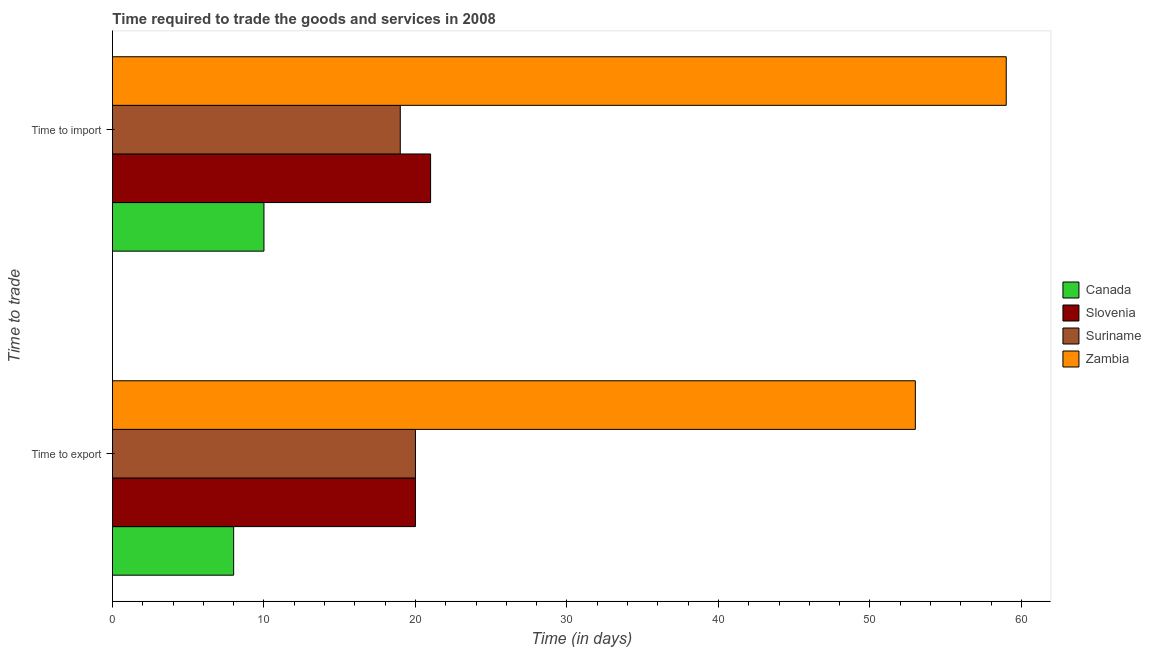Are the number of bars on each tick of the Y-axis equal?
Offer a very short reply. Yes. How many bars are there on the 2nd tick from the bottom?
Your answer should be compact. 4. What is the label of the 2nd group of bars from the top?
Ensure brevity in your answer.  Time to export. What is the time to import in Zambia?
Offer a terse response. 59. Across all countries, what is the maximum time to export?
Your answer should be very brief. 53. Across all countries, what is the minimum time to export?
Your response must be concise. 8. In which country was the time to export maximum?
Your answer should be compact. Zambia. In which country was the time to import minimum?
Offer a terse response. Canada. What is the total time to import in the graph?
Offer a terse response. 109. What is the difference between the time to import in Slovenia and that in Suriname?
Offer a very short reply. 2. What is the difference between the time to export in Suriname and the time to import in Canada?
Your answer should be compact. 10. What is the average time to import per country?
Offer a very short reply. 27.25. What is the difference between the time to import and time to export in Slovenia?
Offer a very short reply. 1. What is the ratio of the time to import in Zambia to that in Suriname?
Make the answer very short. 3.11. Is the time to export in Canada less than that in Zambia?
Your answer should be compact. Yes. In how many countries, is the time to import greater than the average time to import taken over all countries?
Your answer should be compact. 1. What does the 1st bar from the bottom in Time to export represents?
Ensure brevity in your answer.  Canada. How many bars are there?
Give a very brief answer. 8. How many countries are there in the graph?
Ensure brevity in your answer.  4. Does the graph contain any zero values?
Offer a terse response. No. How many legend labels are there?
Give a very brief answer. 4. What is the title of the graph?
Ensure brevity in your answer.  Time required to trade the goods and services in 2008. Does "St. Vincent and the Grenadines" appear as one of the legend labels in the graph?
Offer a terse response. No. What is the label or title of the X-axis?
Your answer should be very brief. Time (in days). What is the label or title of the Y-axis?
Your answer should be very brief. Time to trade. What is the Time (in days) of Canada in Time to export?
Give a very brief answer. 8. What is the Time (in days) of Slovenia in Time to export?
Offer a very short reply. 20. What is the Time (in days) of Suriname in Time to export?
Your response must be concise. 20. What is the Time (in days) in Zambia in Time to export?
Your answer should be very brief. 53. What is the Time (in days) in Slovenia in Time to import?
Keep it short and to the point. 21. What is the Time (in days) in Suriname in Time to import?
Provide a succinct answer. 19. What is the Time (in days) of Zambia in Time to import?
Offer a very short reply. 59. Across all Time to trade, what is the maximum Time (in days) of Slovenia?
Offer a terse response. 21. Across all Time to trade, what is the minimum Time (in days) of Slovenia?
Give a very brief answer. 20. Across all Time to trade, what is the minimum Time (in days) of Zambia?
Ensure brevity in your answer.  53. What is the total Time (in days) of Slovenia in the graph?
Offer a very short reply. 41. What is the total Time (in days) in Suriname in the graph?
Keep it short and to the point. 39. What is the total Time (in days) of Zambia in the graph?
Your response must be concise. 112. What is the difference between the Time (in days) of Suriname in Time to export and that in Time to import?
Your answer should be compact. 1. What is the difference between the Time (in days) of Zambia in Time to export and that in Time to import?
Your answer should be compact. -6. What is the difference between the Time (in days) of Canada in Time to export and the Time (in days) of Zambia in Time to import?
Provide a succinct answer. -51. What is the difference between the Time (in days) in Slovenia in Time to export and the Time (in days) in Suriname in Time to import?
Offer a very short reply. 1. What is the difference between the Time (in days) of Slovenia in Time to export and the Time (in days) of Zambia in Time to import?
Provide a short and direct response. -39. What is the difference between the Time (in days) of Suriname in Time to export and the Time (in days) of Zambia in Time to import?
Your response must be concise. -39. What is the average Time (in days) in Slovenia per Time to trade?
Provide a succinct answer. 20.5. What is the difference between the Time (in days) in Canada and Time (in days) in Zambia in Time to export?
Your answer should be very brief. -45. What is the difference between the Time (in days) of Slovenia and Time (in days) of Suriname in Time to export?
Ensure brevity in your answer.  0. What is the difference between the Time (in days) of Slovenia and Time (in days) of Zambia in Time to export?
Give a very brief answer. -33. What is the difference between the Time (in days) in Suriname and Time (in days) in Zambia in Time to export?
Provide a short and direct response. -33. What is the difference between the Time (in days) in Canada and Time (in days) in Slovenia in Time to import?
Give a very brief answer. -11. What is the difference between the Time (in days) of Canada and Time (in days) of Suriname in Time to import?
Offer a terse response. -9. What is the difference between the Time (in days) of Canada and Time (in days) of Zambia in Time to import?
Make the answer very short. -49. What is the difference between the Time (in days) of Slovenia and Time (in days) of Zambia in Time to import?
Offer a very short reply. -38. What is the difference between the Time (in days) in Suriname and Time (in days) in Zambia in Time to import?
Keep it short and to the point. -40. What is the ratio of the Time (in days) in Slovenia in Time to export to that in Time to import?
Ensure brevity in your answer.  0.95. What is the ratio of the Time (in days) of Suriname in Time to export to that in Time to import?
Provide a short and direct response. 1.05. What is the ratio of the Time (in days) in Zambia in Time to export to that in Time to import?
Make the answer very short. 0.9. What is the difference between the highest and the second highest Time (in days) of Canada?
Your answer should be compact. 2. What is the difference between the highest and the lowest Time (in days) of Canada?
Your answer should be very brief. 2. What is the difference between the highest and the lowest Time (in days) of Slovenia?
Keep it short and to the point. 1. What is the difference between the highest and the lowest Time (in days) in Zambia?
Provide a succinct answer. 6. 